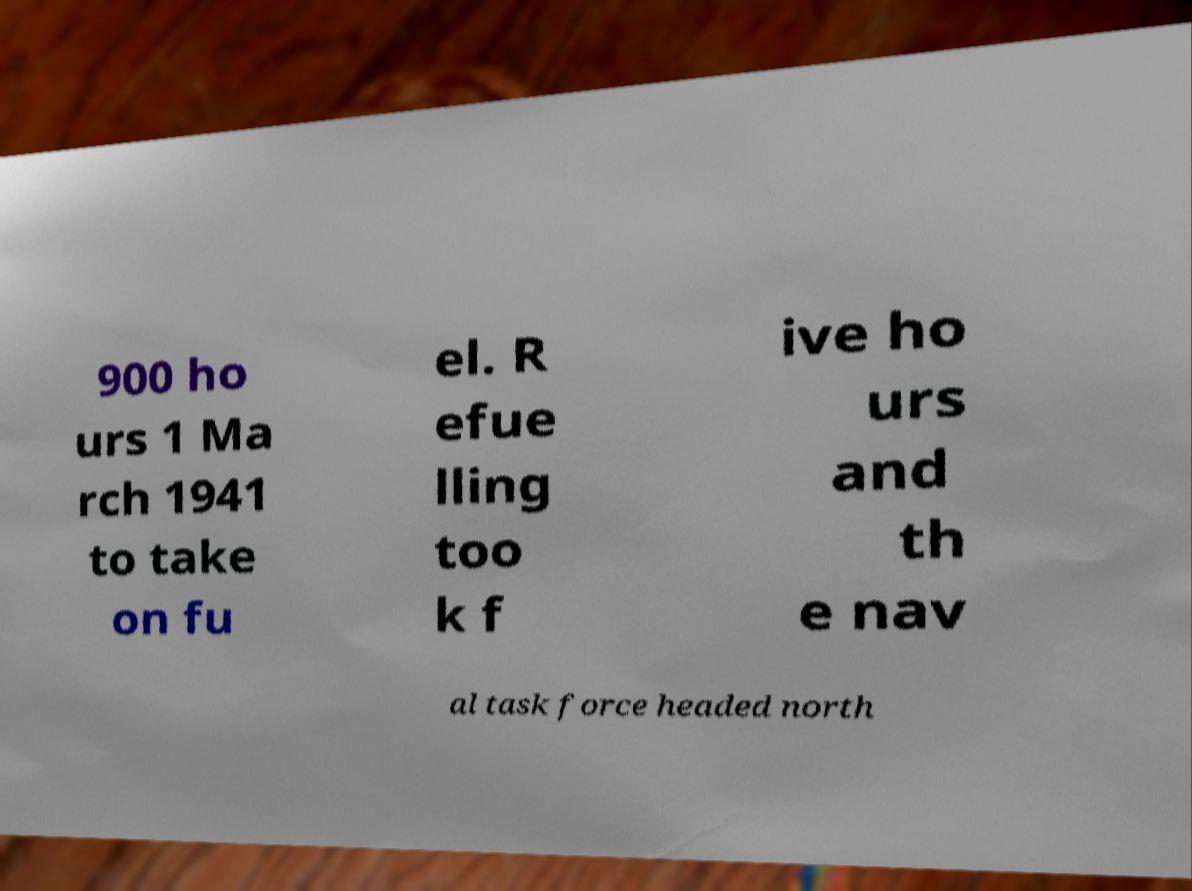Could you extract and type out the text from this image? 900 ho urs 1 Ma rch 1941 to take on fu el. R efue lling too k f ive ho urs and th e nav al task force headed north 